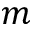<formula> <loc_0><loc_0><loc_500><loc_500>m</formula> 